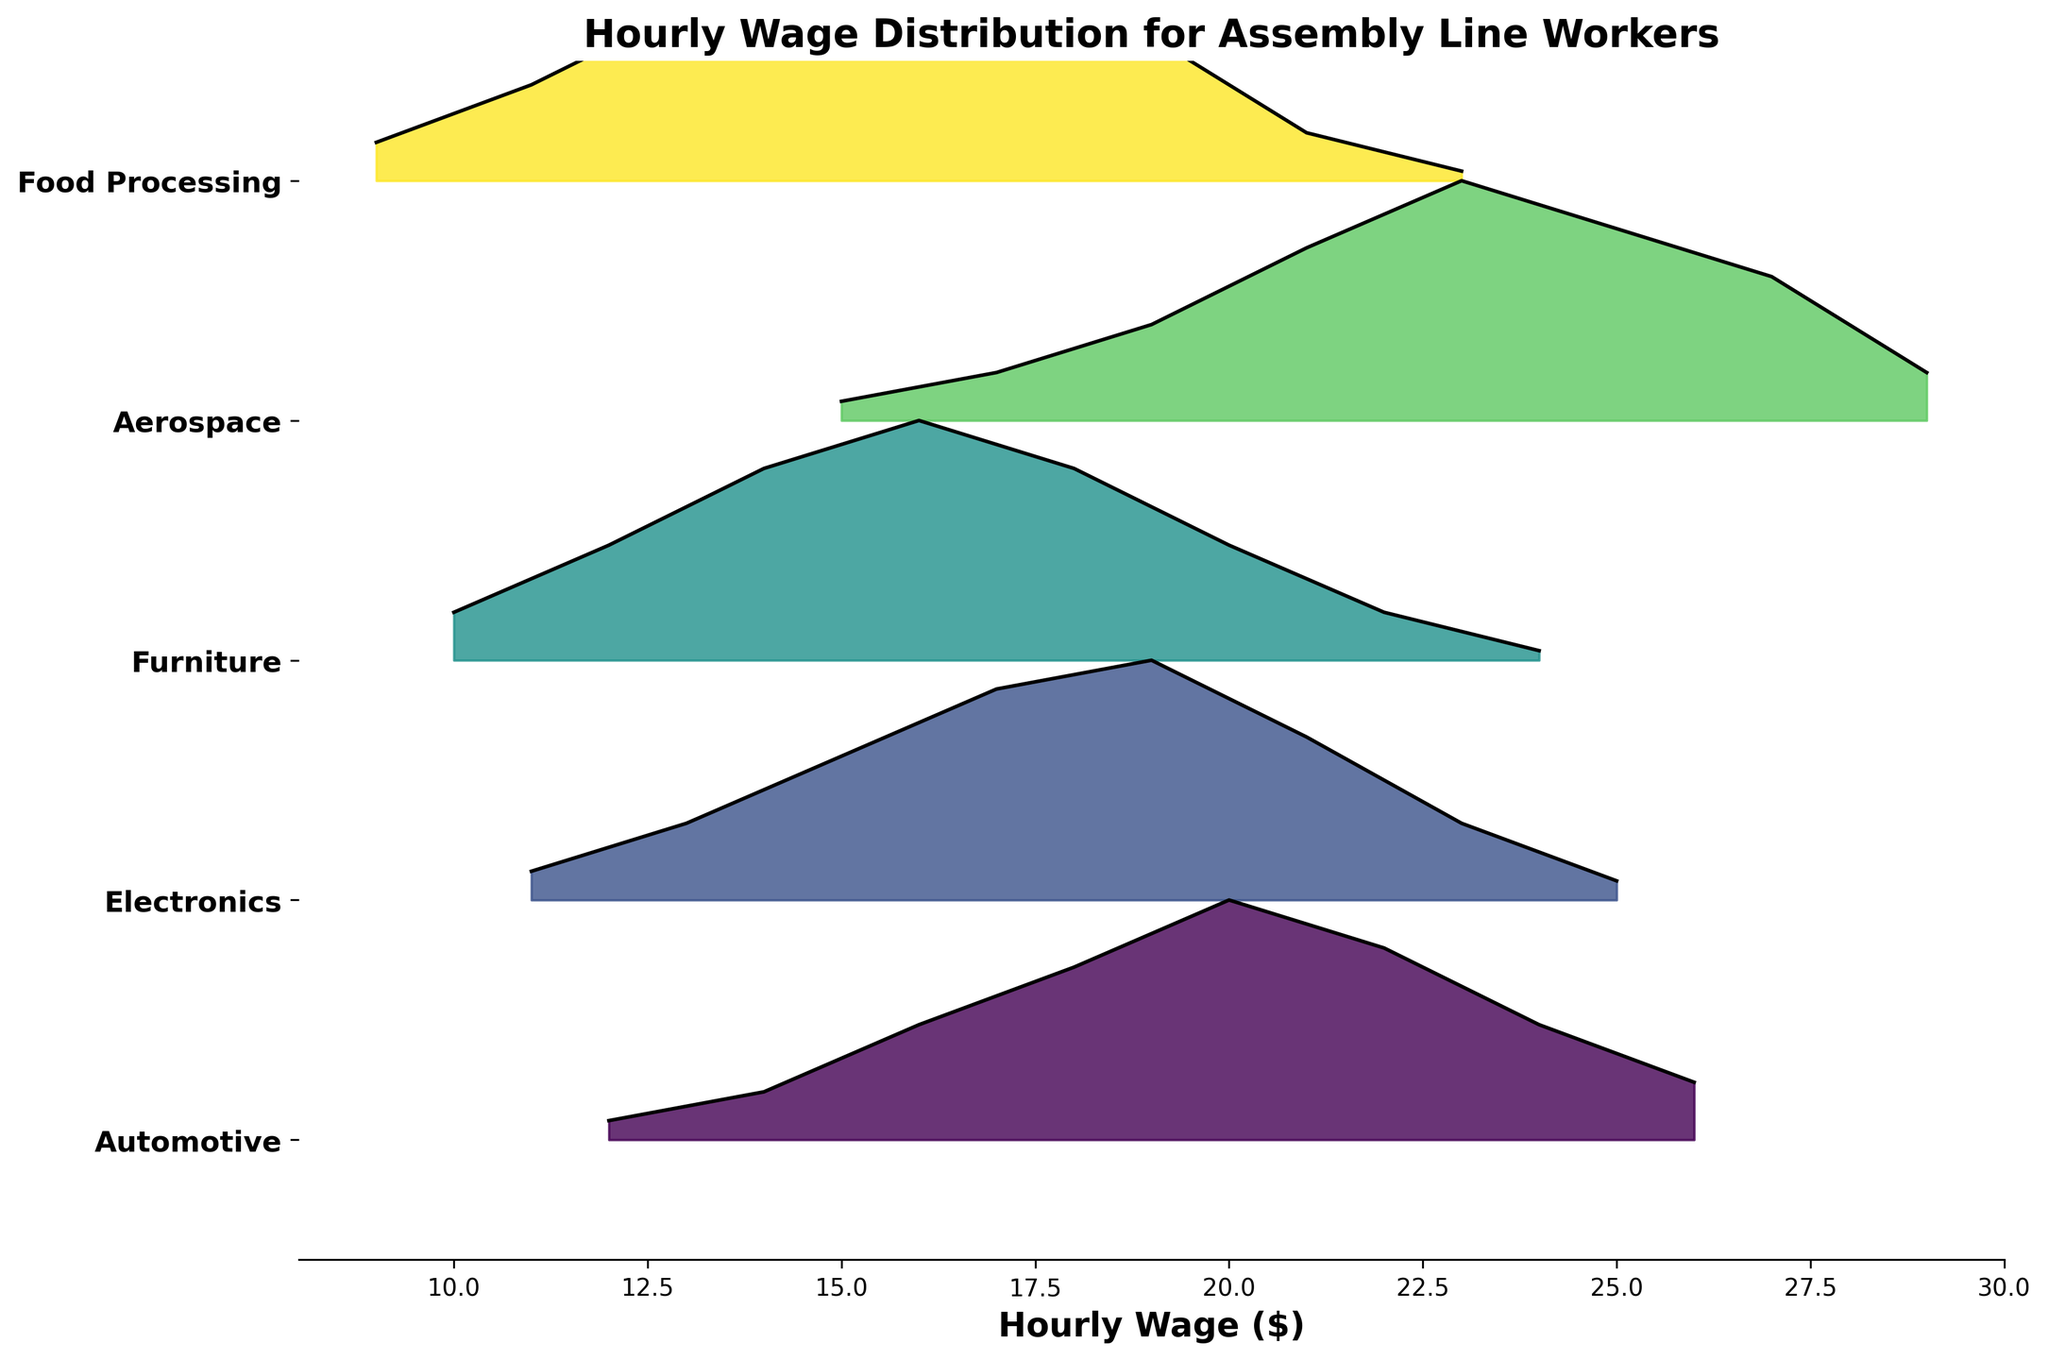What's the title of the plot? The title of the plot is clearly written at the top of the figure.
Answer: Hourly Wage Distribution for Assembly Line Workers What is the x-axis labeled as? The x-axis label is described at the bottom of the plot.
Answer: Hourly Wage ($) How many manufacturing sectors are displayed in the plot? There are separate ridgelines for each manufacturing sector shown. Counting them gives the total number.
Answer: 5 In which sector do the workers have the highest density at the lowest wage? By examining the ridgeline plots and identifying the one with the highest density peak at the lowest wage, we find the sector.
Answer: Food Processing Which sector seems to have the highest maximum hourly wage? By looking at the farthest point to the right on the respective ridgeline plots, the sector with the maximum hourly wage can be identified.
Answer: Aerospace At what wage does the Electronics sector reach its peak density? The Electronics sector's peak density is the tallest point on its ridgeline plot. The corresponding wage is noted at this peak.
Answer: $19 Compare the peak density wage between Automotive and Furniture sectors. Which sector has a higher peak density wage and what are they? Check the tallest points on the ridgelines of Automotive and Furniture sectors and note their corresponding wages.
Answer: Furniture at $16, Automotive at $20 What is the average wage with the highest density across all sectors? Identify the wages with the highest densities in each sector and calculate their average. E.g., Automotive $20, Electronics $19, Furniture $16, Aerospace $23, Food Processing $15. Average = ($20+$19+$16+$23+$15)/5.
Answer: $18.60 Which sector has the most evenly distributed wages? Look for the ridgeline where the density is evenly spread out without sharp peaks, indicating even distribution.
Answer: Food Processing How does the hourly wage distribution for the Aerospace sector compare to the Automotive sector? Compare the ridgeline plots of Aerospace and Automotive sectors to determine differences in wage distribution patterns such as range, peak densities, and spread.
Answer: Aerospace has higher wages and more spread-out distribution compared to Automotive 